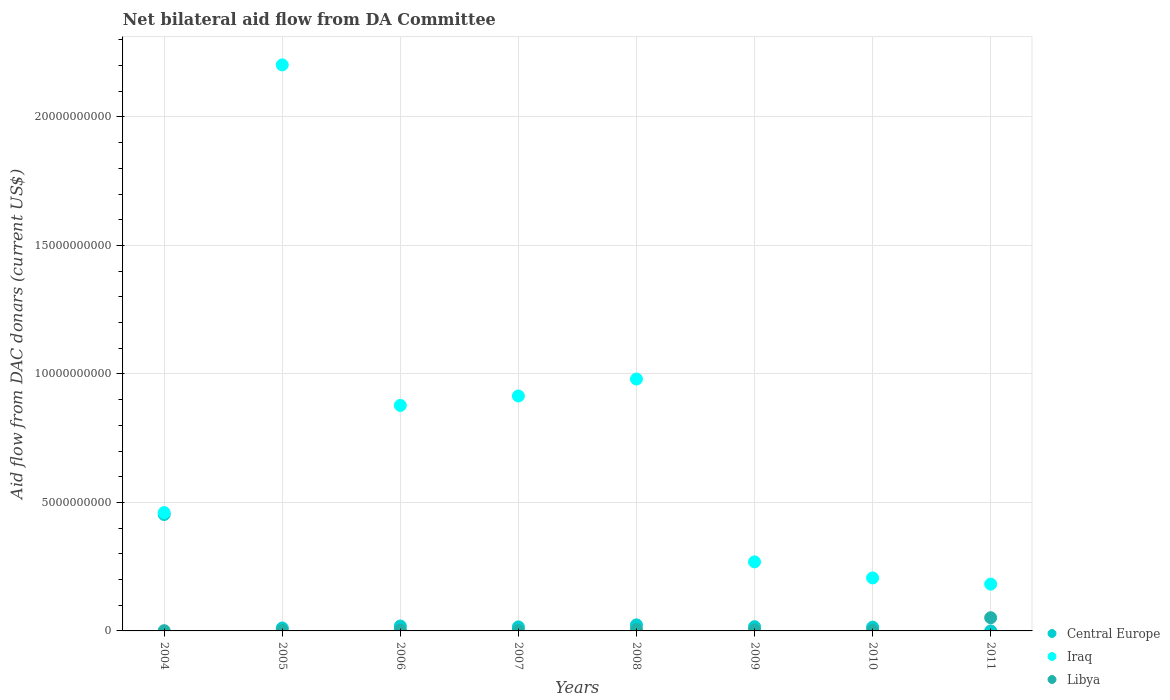How many different coloured dotlines are there?
Your answer should be compact. 3. What is the aid flow in in Libya in 2008?
Provide a succinct answer. 5.66e+07. Across all years, what is the maximum aid flow in in Iraq?
Your answer should be compact. 2.20e+1. Across all years, what is the minimum aid flow in in Iraq?
Your response must be concise. 1.82e+09. In which year was the aid flow in in Iraq minimum?
Ensure brevity in your answer.  2011. What is the total aid flow in in Iraq in the graph?
Your answer should be compact. 6.09e+1. What is the difference between the aid flow in in Central Europe in 2008 and that in 2010?
Provide a short and direct response. 8.90e+07. What is the difference between the aid flow in in Central Europe in 2006 and the aid flow in in Iraq in 2005?
Keep it short and to the point. -2.18e+1. What is the average aid flow in in Iraq per year?
Offer a terse response. 7.62e+09. In the year 2005, what is the difference between the aid flow in in Central Europe and aid flow in in Iraq?
Your answer should be compact. -2.19e+1. In how many years, is the aid flow in in Libya greater than 5000000000 US$?
Ensure brevity in your answer.  0. What is the ratio of the aid flow in in Iraq in 2004 to that in 2011?
Keep it short and to the point. 2.53. Is the aid flow in in Libya in 2004 less than that in 2008?
Make the answer very short. Yes. Is the difference between the aid flow in in Central Europe in 2007 and 2009 greater than the difference between the aid flow in in Iraq in 2007 and 2009?
Give a very brief answer. No. What is the difference between the highest and the second highest aid flow in in Iraq?
Your answer should be compact. 1.22e+1. What is the difference between the highest and the lowest aid flow in in Iraq?
Your answer should be compact. 2.02e+1. Is the aid flow in in Iraq strictly greater than the aid flow in in Libya over the years?
Your answer should be compact. Yes. Is the aid flow in in Libya strictly less than the aid flow in in Central Europe over the years?
Your answer should be compact. No. How many years are there in the graph?
Keep it short and to the point. 8. What is the difference between two consecutive major ticks on the Y-axis?
Offer a terse response. 5.00e+09. Are the values on the major ticks of Y-axis written in scientific E-notation?
Provide a short and direct response. No. Does the graph contain any zero values?
Offer a very short reply. No. Where does the legend appear in the graph?
Make the answer very short. Bottom right. How many legend labels are there?
Your response must be concise. 3. How are the legend labels stacked?
Your response must be concise. Vertical. What is the title of the graph?
Provide a short and direct response. Net bilateral aid flow from DA Committee. What is the label or title of the X-axis?
Make the answer very short. Years. What is the label or title of the Y-axis?
Ensure brevity in your answer.  Aid flow from DAC donars (current US$). What is the Aid flow from DAC donars (current US$) in Central Europe in 2004?
Your answer should be very brief. 4.53e+09. What is the Aid flow from DAC donars (current US$) of Iraq in 2004?
Offer a terse response. 4.61e+09. What is the Aid flow from DAC donars (current US$) in Libya in 2004?
Your response must be concise. 9.70e+06. What is the Aid flow from DAC donars (current US$) of Central Europe in 2005?
Your answer should be very brief. 1.14e+08. What is the Aid flow from DAC donars (current US$) of Iraq in 2005?
Provide a succinct answer. 2.20e+1. What is the Aid flow from DAC donars (current US$) of Libya in 2005?
Your response must be concise. 1.76e+07. What is the Aid flow from DAC donars (current US$) in Central Europe in 2006?
Your answer should be very brief. 1.90e+08. What is the Aid flow from DAC donars (current US$) in Iraq in 2006?
Your answer should be compact. 8.78e+09. What is the Aid flow from DAC donars (current US$) in Libya in 2006?
Ensure brevity in your answer.  3.43e+07. What is the Aid flow from DAC donars (current US$) of Central Europe in 2007?
Offer a very short reply. 1.56e+08. What is the Aid flow from DAC donars (current US$) of Iraq in 2007?
Ensure brevity in your answer.  9.14e+09. What is the Aid flow from DAC donars (current US$) of Libya in 2007?
Give a very brief answer. 1.67e+07. What is the Aid flow from DAC donars (current US$) of Central Europe in 2008?
Offer a very short reply. 2.35e+08. What is the Aid flow from DAC donars (current US$) of Iraq in 2008?
Your response must be concise. 9.80e+09. What is the Aid flow from DAC donars (current US$) in Libya in 2008?
Give a very brief answer. 5.66e+07. What is the Aid flow from DAC donars (current US$) in Central Europe in 2009?
Make the answer very short. 1.65e+08. What is the Aid flow from DAC donars (current US$) of Iraq in 2009?
Your answer should be compact. 2.69e+09. What is the Aid flow from DAC donars (current US$) in Libya in 2009?
Keep it short and to the point. 3.46e+07. What is the Aid flow from DAC donars (current US$) of Central Europe in 2010?
Keep it short and to the point. 1.46e+08. What is the Aid flow from DAC donars (current US$) of Iraq in 2010?
Your response must be concise. 2.06e+09. What is the Aid flow from DAC donars (current US$) of Libya in 2010?
Offer a terse response. 1.84e+07. What is the Aid flow from DAC donars (current US$) of Iraq in 2011?
Make the answer very short. 1.82e+09. What is the Aid flow from DAC donars (current US$) of Libya in 2011?
Your answer should be very brief. 5.14e+08. Across all years, what is the maximum Aid flow from DAC donars (current US$) in Central Europe?
Offer a very short reply. 4.53e+09. Across all years, what is the maximum Aid flow from DAC donars (current US$) of Iraq?
Offer a very short reply. 2.20e+1. Across all years, what is the maximum Aid flow from DAC donars (current US$) of Libya?
Ensure brevity in your answer.  5.14e+08. Across all years, what is the minimum Aid flow from DAC donars (current US$) of Central Europe?
Offer a very short reply. 2.80e+05. Across all years, what is the minimum Aid flow from DAC donars (current US$) of Iraq?
Your response must be concise. 1.82e+09. Across all years, what is the minimum Aid flow from DAC donars (current US$) in Libya?
Give a very brief answer. 9.70e+06. What is the total Aid flow from DAC donars (current US$) in Central Europe in the graph?
Ensure brevity in your answer.  5.54e+09. What is the total Aid flow from DAC donars (current US$) in Iraq in the graph?
Keep it short and to the point. 6.09e+1. What is the total Aid flow from DAC donars (current US$) of Libya in the graph?
Ensure brevity in your answer.  7.02e+08. What is the difference between the Aid flow from DAC donars (current US$) of Central Europe in 2004 and that in 2005?
Provide a succinct answer. 4.42e+09. What is the difference between the Aid flow from DAC donars (current US$) of Iraq in 2004 and that in 2005?
Provide a short and direct response. -1.74e+1. What is the difference between the Aid flow from DAC donars (current US$) in Libya in 2004 and that in 2005?
Your response must be concise. -7.91e+06. What is the difference between the Aid flow from DAC donars (current US$) in Central Europe in 2004 and that in 2006?
Make the answer very short. 4.34e+09. What is the difference between the Aid flow from DAC donars (current US$) in Iraq in 2004 and that in 2006?
Make the answer very short. -4.17e+09. What is the difference between the Aid flow from DAC donars (current US$) in Libya in 2004 and that in 2006?
Offer a very short reply. -2.46e+07. What is the difference between the Aid flow from DAC donars (current US$) in Central Europe in 2004 and that in 2007?
Keep it short and to the point. 4.37e+09. What is the difference between the Aid flow from DAC donars (current US$) of Iraq in 2004 and that in 2007?
Make the answer very short. -4.54e+09. What is the difference between the Aid flow from DAC donars (current US$) of Libya in 2004 and that in 2007?
Your response must be concise. -7.00e+06. What is the difference between the Aid flow from DAC donars (current US$) of Central Europe in 2004 and that in 2008?
Give a very brief answer. 4.30e+09. What is the difference between the Aid flow from DAC donars (current US$) in Iraq in 2004 and that in 2008?
Provide a succinct answer. -5.20e+09. What is the difference between the Aid flow from DAC donars (current US$) in Libya in 2004 and that in 2008?
Your answer should be compact. -4.69e+07. What is the difference between the Aid flow from DAC donars (current US$) of Central Europe in 2004 and that in 2009?
Ensure brevity in your answer.  4.37e+09. What is the difference between the Aid flow from DAC donars (current US$) in Iraq in 2004 and that in 2009?
Provide a short and direct response. 1.92e+09. What is the difference between the Aid flow from DAC donars (current US$) in Libya in 2004 and that in 2009?
Your response must be concise. -2.49e+07. What is the difference between the Aid flow from DAC donars (current US$) in Central Europe in 2004 and that in 2010?
Offer a terse response. 4.38e+09. What is the difference between the Aid flow from DAC donars (current US$) of Iraq in 2004 and that in 2010?
Keep it short and to the point. 2.54e+09. What is the difference between the Aid flow from DAC donars (current US$) in Libya in 2004 and that in 2010?
Your response must be concise. -8.75e+06. What is the difference between the Aid flow from DAC donars (current US$) of Central Europe in 2004 and that in 2011?
Give a very brief answer. 4.53e+09. What is the difference between the Aid flow from DAC donars (current US$) in Iraq in 2004 and that in 2011?
Your response must be concise. 2.78e+09. What is the difference between the Aid flow from DAC donars (current US$) of Libya in 2004 and that in 2011?
Offer a terse response. -5.04e+08. What is the difference between the Aid flow from DAC donars (current US$) of Central Europe in 2005 and that in 2006?
Your answer should be compact. -7.64e+07. What is the difference between the Aid flow from DAC donars (current US$) of Iraq in 2005 and that in 2006?
Ensure brevity in your answer.  1.33e+1. What is the difference between the Aid flow from DAC donars (current US$) of Libya in 2005 and that in 2006?
Keep it short and to the point. -1.67e+07. What is the difference between the Aid flow from DAC donars (current US$) of Central Europe in 2005 and that in 2007?
Give a very brief answer. -4.23e+07. What is the difference between the Aid flow from DAC donars (current US$) of Iraq in 2005 and that in 2007?
Provide a short and direct response. 1.29e+1. What is the difference between the Aid flow from DAC donars (current US$) of Libya in 2005 and that in 2007?
Your response must be concise. 9.10e+05. What is the difference between the Aid flow from DAC donars (current US$) of Central Europe in 2005 and that in 2008?
Offer a terse response. -1.21e+08. What is the difference between the Aid flow from DAC donars (current US$) of Iraq in 2005 and that in 2008?
Ensure brevity in your answer.  1.22e+1. What is the difference between the Aid flow from DAC donars (current US$) in Libya in 2005 and that in 2008?
Provide a short and direct response. -3.90e+07. What is the difference between the Aid flow from DAC donars (current US$) of Central Europe in 2005 and that in 2009?
Your answer should be compact. -5.08e+07. What is the difference between the Aid flow from DAC donars (current US$) of Iraq in 2005 and that in 2009?
Provide a succinct answer. 1.93e+1. What is the difference between the Aid flow from DAC donars (current US$) of Libya in 2005 and that in 2009?
Offer a terse response. -1.70e+07. What is the difference between the Aid flow from DAC donars (current US$) of Central Europe in 2005 and that in 2010?
Your answer should be very brief. -3.20e+07. What is the difference between the Aid flow from DAC donars (current US$) of Iraq in 2005 and that in 2010?
Offer a very short reply. 2.00e+1. What is the difference between the Aid flow from DAC donars (current US$) of Libya in 2005 and that in 2010?
Provide a short and direct response. -8.40e+05. What is the difference between the Aid flow from DAC donars (current US$) in Central Europe in 2005 and that in 2011?
Provide a short and direct response. 1.14e+08. What is the difference between the Aid flow from DAC donars (current US$) of Iraq in 2005 and that in 2011?
Offer a very short reply. 2.02e+1. What is the difference between the Aid flow from DAC donars (current US$) in Libya in 2005 and that in 2011?
Give a very brief answer. -4.96e+08. What is the difference between the Aid flow from DAC donars (current US$) in Central Europe in 2006 and that in 2007?
Your answer should be compact. 3.41e+07. What is the difference between the Aid flow from DAC donars (current US$) in Iraq in 2006 and that in 2007?
Offer a very short reply. -3.67e+08. What is the difference between the Aid flow from DAC donars (current US$) of Libya in 2006 and that in 2007?
Your response must be concise. 1.76e+07. What is the difference between the Aid flow from DAC donars (current US$) of Central Europe in 2006 and that in 2008?
Your response must be concise. -4.46e+07. What is the difference between the Aid flow from DAC donars (current US$) in Iraq in 2006 and that in 2008?
Make the answer very short. -1.03e+09. What is the difference between the Aid flow from DAC donars (current US$) in Libya in 2006 and that in 2008?
Your answer should be compact. -2.23e+07. What is the difference between the Aid flow from DAC donars (current US$) of Central Europe in 2006 and that in 2009?
Your answer should be very brief. 2.56e+07. What is the difference between the Aid flow from DAC donars (current US$) of Iraq in 2006 and that in 2009?
Your answer should be compact. 6.09e+09. What is the difference between the Aid flow from DAC donars (current US$) in Central Europe in 2006 and that in 2010?
Give a very brief answer. 4.43e+07. What is the difference between the Aid flow from DAC donars (current US$) in Iraq in 2006 and that in 2010?
Ensure brevity in your answer.  6.71e+09. What is the difference between the Aid flow from DAC donars (current US$) of Libya in 2006 and that in 2010?
Offer a very short reply. 1.59e+07. What is the difference between the Aid flow from DAC donars (current US$) in Central Europe in 2006 and that in 2011?
Your answer should be compact. 1.90e+08. What is the difference between the Aid flow from DAC donars (current US$) of Iraq in 2006 and that in 2011?
Provide a short and direct response. 6.95e+09. What is the difference between the Aid flow from DAC donars (current US$) of Libya in 2006 and that in 2011?
Offer a terse response. -4.80e+08. What is the difference between the Aid flow from DAC donars (current US$) in Central Europe in 2007 and that in 2008?
Your response must be concise. -7.87e+07. What is the difference between the Aid flow from DAC donars (current US$) in Iraq in 2007 and that in 2008?
Your answer should be compact. -6.60e+08. What is the difference between the Aid flow from DAC donars (current US$) in Libya in 2007 and that in 2008?
Provide a succinct answer. -3.99e+07. What is the difference between the Aid flow from DAC donars (current US$) of Central Europe in 2007 and that in 2009?
Your answer should be compact. -8.51e+06. What is the difference between the Aid flow from DAC donars (current US$) of Iraq in 2007 and that in 2009?
Your response must be concise. 6.46e+09. What is the difference between the Aid flow from DAC donars (current US$) of Libya in 2007 and that in 2009?
Your response must be concise. -1.79e+07. What is the difference between the Aid flow from DAC donars (current US$) in Central Europe in 2007 and that in 2010?
Make the answer very short. 1.03e+07. What is the difference between the Aid flow from DAC donars (current US$) of Iraq in 2007 and that in 2010?
Offer a very short reply. 7.08e+09. What is the difference between the Aid flow from DAC donars (current US$) of Libya in 2007 and that in 2010?
Your answer should be very brief. -1.75e+06. What is the difference between the Aid flow from DAC donars (current US$) of Central Europe in 2007 and that in 2011?
Offer a terse response. 1.56e+08. What is the difference between the Aid flow from DAC donars (current US$) in Iraq in 2007 and that in 2011?
Give a very brief answer. 7.32e+09. What is the difference between the Aid flow from DAC donars (current US$) in Libya in 2007 and that in 2011?
Your response must be concise. -4.97e+08. What is the difference between the Aid flow from DAC donars (current US$) in Central Europe in 2008 and that in 2009?
Give a very brief answer. 7.02e+07. What is the difference between the Aid flow from DAC donars (current US$) of Iraq in 2008 and that in 2009?
Offer a very short reply. 7.12e+09. What is the difference between the Aid flow from DAC donars (current US$) in Libya in 2008 and that in 2009?
Your response must be concise. 2.20e+07. What is the difference between the Aid flow from DAC donars (current US$) of Central Europe in 2008 and that in 2010?
Ensure brevity in your answer.  8.90e+07. What is the difference between the Aid flow from DAC donars (current US$) in Iraq in 2008 and that in 2010?
Provide a short and direct response. 7.74e+09. What is the difference between the Aid flow from DAC donars (current US$) of Libya in 2008 and that in 2010?
Offer a very short reply. 3.81e+07. What is the difference between the Aid flow from DAC donars (current US$) of Central Europe in 2008 and that in 2011?
Your answer should be compact. 2.35e+08. What is the difference between the Aid flow from DAC donars (current US$) of Iraq in 2008 and that in 2011?
Offer a very short reply. 7.98e+09. What is the difference between the Aid flow from DAC donars (current US$) in Libya in 2008 and that in 2011?
Make the answer very short. -4.58e+08. What is the difference between the Aid flow from DAC donars (current US$) in Central Europe in 2009 and that in 2010?
Offer a terse response. 1.88e+07. What is the difference between the Aid flow from DAC donars (current US$) in Iraq in 2009 and that in 2010?
Provide a succinct answer. 6.25e+08. What is the difference between the Aid flow from DAC donars (current US$) of Libya in 2009 and that in 2010?
Keep it short and to the point. 1.61e+07. What is the difference between the Aid flow from DAC donars (current US$) of Central Europe in 2009 and that in 2011?
Your response must be concise. 1.65e+08. What is the difference between the Aid flow from DAC donars (current US$) in Iraq in 2009 and that in 2011?
Give a very brief answer. 8.66e+08. What is the difference between the Aid flow from DAC donars (current US$) in Libya in 2009 and that in 2011?
Your answer should be very brief. -4.80e+08. What is the difference between the Aid flow from DAC donars (current US$) in Central Europe in 2010 and that in 2011?
Make the answer very short. 1.46e+08. What is the difference between the Aid flow from DAC donars (current US$) of Iraq in 2010 and that in 2011?
Keep it short and to the point. 2.41e+08. What is the difference between the Aid flow from DAC donars (current US$) of Libya in 2010 and that in 2011?
Make the answer very short. -4.96e+08. What is the difference between the Aid flow from DAC donars (current US$) in Central Europe in 2004 and the Aid flow from DAC donars (current US$) in Iraq in 2005?
Provide a succinct answer. -1.75e+1. What is the difference between the Aid flow from DAC donars (current US$) of Central Europe in 2004 and the Aid flow from DAC donars (current US$) of Libya in 2005?
Make the answer very short. 4.51e+09. What is the difference between the Aid flow from DAC donars (current US$) of Iraq in 2004 and the Aid flow from DAC donars (current US$) of Libya in 2005?
Give a very brief answer. 4.59e+09. What is the difference between the Aid flow from DAC donars (current US$) of Central Europe in 2004 and the Aid flow from DAC donars (current US$) of Iraq in 2006?
Keep it short and to the point. -4.24e+09. What is the difference between the Aid flow from DAC donars (current US$) in Central Europe in 2004 and the Aid flow from DAC donars (current US$) in Libya in 2006?
Offer a terse response. 4.50e+09. What is the difference between the Aid flow from DAC donars (current US$) of Iraq in 2004 and the Aid flow from DAC donars (current US$) of Libya in 2006?
Ensure brevity in your answer.  4.57e+09. What is the difference between the Aid flow from DAC donars (current US$) of Central Europe in 2004 and the Aid flow from DAC donars (current US$) of Iraq in 2007?
Your answer should be very brief. -4.61e+09. What is the difference between the Aid flow from DAC donars (current US$) in Central Europe in 2004 and the Aid flow from DAC donars (current US$) in Libya in 2007?
Offer a very short reply. 4.51e+09. What is the difference between the Aid flow from DAC donars (current US$) of Iraq in 2004 and the Aid flow from DAC donars (current US$) of Libya in 2007?
Keep it short and to the point. 4.59e+09. What is the difference between the Aid flow from DAC donars (current US$) of Central Europe in 2004 and the Aid flow from DAC donars (current US$) of Iraq in 2008?
Ensure brevity in your answer.  -5.27e+09. What is the difference between the Aid flow from DAC donars (current US$) in Central Europe in 2004 and the Aid flow from DAC donars (current US$) in Libya in 2008?
Provide a succinct answer. 4.47e+09. What is the difference between the Aid flow from DAC donars (current US$) of Iraq in 2004 and the Aid flow from DAC donars (current US$) of Libya in 2008?
Provide a succinct answer. 4.55e+09. What is the difference between the Aid flow from DAC donars (current US$) in Central Europe in 2004 and the Aid flow from DAC donars (current US$) in Iraq in 2009?
Your response must be concise. 1.84e+09. What is the difference between the Aid flow from DAC donars (current US$) in Central Europe in 2004 and the Aid flow from DAC donars (current US$) in Libya in 2009?
Your answer should be compact. 4.50e+09. What is the difference between the Aid flow from DAC donars (current US$) in Iraq in 2004 and the Aid flow from DAC donars (current US$) in Libya in 2009?
Provide a short and direct response. 4.57e+09. What is the difference between the Aid flow from DAC donars (current US$) of Central Europe in 2004 and the Aid flow from DAC donars (current US$) of Iraq in 2010?
Provide a short and direct response. 2.47e+09. What is the difference between the Aid flow from DAC donars (current US$) of Central Europe in 2004 and the Aid flow from DAC donars (current US$) of Libya in 2010?
Give a very brief answer. 4.51e+09. What is the difference between the Aid flow from DAC donars (current US$) of Iraq in 2004 and the Aid flow from DAC donars (current US$) of Libya in 2010?
Make the answer very short. 4.59e+09. What is the difference between the Aid flow from DAC donars (current US$) in Central Europe in 2004 and the Aid flow from DAC donars (current US$) in Iraq in 2011?
Provide a succinct answer. 2.71e+09. What is the difference between the Aid flow from DAC donars (current US$) in Central Europe in 2004 and the Aid flow from DAC donars (current US$) in Libya in 2011?
Your answer should be very brief. 4.02e+09. What is the difference between the Aid flow from DAC donars (current US$) in Iraq in 2004 and the Aid flow from DAC donars (current US$) in Libya in 2011?
Provide a short and direct response. 4.09e+09. What is the difference between the Aid flow from DAC donars (current US$) of Central Europe in 2005 and the Aid flow from DAC donars (current US$) of Iraq in 2006?
Offer a terse response. -8.66e+09. What is the difference between the Aid flow from DAC donars (current US$) in Central Europe in 2005 and the Aid flow from DAC donars (current US$) in Libya in 2006?
Provide a short and direct response. 7.98e+07. What is the difference between the Aid flow from DAC donars (current US$) in Iraq in 2005 and the Aid flow from DAC donars (current US$) in Libya in 2006?
Offer a very short reply. 2.20e+1. What is the difference between the Aid flow from DAC donars (current US$) of Central Europe in 2005 and the Aid flow from DAC donars (current US$) of Iraq in 2007?
Provide a short and direct response. -9.03e+09. What is the difference between the Aid flow from DAC donars (current US$) in Central Europe in 2005 and the Aid flow from DAC donars (current US$) in Libya in 2007?
Make the answer very short. 9.74e+07. What is the difference between the Aid flow from DAC donars (current US$) of Iraq in 2005 and the Aid flow from DAC donars (current US$) of Libya in 2007?
Offer a terse response. 2.20e+1. What is the difference between the Aid flow from DAC donars (current US$) in Central Europe in 2005 and the Aid flow from DAC donars (current US$) in Iraq in 2008?
Provide a short and direct response. -9.69e+09. What is the difference between the Aid flow from DAC donars (current US$) in Central Europe in 2005 and the Aid flow from DAC donars (current US$) in Libya in 2008?
Keep it short and to the point. 5.75e+07. What is the difference between the Aid flow from DAC donars (current US$) in Iraq in 2005 and the Aid flow from DAC donars (current US$) in Libya in 2008?
Your answer should be very brief. 2.20e+1. What is the difference between the Aid flow from DAC donars (current US$) in Central Europe in 2005 and the Aid flow from DAC donars (current US$) in Iraq in 2009?
Make the answer very short. -2.57e+09. What is the difference between the Aid flow from DAC donars (current US$) of Central Europe in 2005 and the Aid flow from DAC donars (current US$) of Libya in 2009?
Make the answer very short. 7.95e+07. What is the difference between the Aid flow from DAC donars (current US$) in Iraq in 2005 and the Aid flow from DAC donars (current US$) in Libya in 2009?
Your answer should be very brief. 2.20e+1. What is the difference between the Aid flow from DAC donars (current US$) of Central Europe in 2005 and the Aid flow from DAC donars (current US$) of Iraq in 2010?
Ensure brevity in your answer.  -1.95e+09. What is the difference between the Aid flow from DAC donars (current US$) in Central Europe in 2005 and the Aid flow from DAC donars (current US$) in Libya in 2010?
Your answer should be very brief. 9.56e+07. What is the difference between the Aid flow from DAC donars (current US$) of Iraq in 2005 and the Aid flow from DAC donars (current US$) of Libya in 2010?
Keep it short and to the point. 2.20e+1. What is the difference between the Aid flow from DAC donars (current US$) of Central Europe in 2005 and the Aid flow from DAC donars (current US$) of Iraq in 2011?
Your answer should be compact. -1.71e+09. What is the difference between the Aid flow from DAC donars (current US$) in Central Europe in 2005 and the Aid flow from DAC donars (current US$) in Libya in 2011?
Your answer should be very brief. -4.00e+08. What is the difference between the Aid flow from DAC donars (current US$) of Iraq in 2005 and the Aid flow from DAC donars (current US$) of Libya in 2011?
Your answer should be compact. 2.15e+1. What is the difference between the Aid flow from DAC donars (current US$) in Central Europe in 2006 and the Aid flow from DAC donars (current US$) in Iraq in 2007?
Offer a very short reply. -8.95e+09. What is the difference between the Aid flow from DAC donars (current US$) of Central Europe in 2006 and the Aid flow from DAC donars (current US$) of Libya in 2007?
Give a very brief answer. 1.74e+08. What is the difference between the Aid flow from DAC donars (current US$) of Iraq in 2006 and the Aid flow from DAC donars (current US$) of Libya in 2007?
Provide a succinct answer. 8.76e+09. What is the difference between the Aid flow from DAC donars (current US$) in Central Europe in 2006 and the Aid flow from DAC donars (current US$) in Iraq in 2008?
Your answer should be very brief. -9.61e+09. What is the difference between the Aid flow from DAC donars (current US$) in Central Europe in 2006 and the Aid flow from DAC donars (current US$) in Libya in 2008?
Provide a short and direct response. 1.34e+08. What is the difference between the Aid flow from DAC donars (current US$) of Iraq in 2006 and the Aid flow from DAC donars (current US$) of Libya in 2008?
Offer a terse response. 8.72e+09. What is the difference between the Aid flow from DAC donars (current US$) in Central Europe in 2006 and the Aid flow from DAC donars (current US$) in Iraq in 2009?
Ensure brevity in your answer.  -2.50e+09. What is the difference between the Aid flow from DAC donars (current US$) of Central Europe in 2006 and the Aid flow from DAC donars (current US$) of Libya in 2009?
Provide a succinct answer. 1.56e+08. What is the difference between the Aid flow from DAC donars (current US$) of Iraq in 2006 and the Aid flow from DAC donars (current US$) of Libya in 2009?
Provide a short and direct response. 8.74e+09. What is the difference between the Aid flow from DAC donars (current US$) of Central Europe in 2006 and the Aid flow from DAC donars (current US$) of Iraq in 2010?
Your answer should be very brief. -1.87e+09. What is the difference between the Aid flow from DAC donars (current US$) in Central Europe in 2006 and the Aid flow from DAC donars (current US$) in Libya in 2010?
Your answer should be compact. 1.72e+08. What is the difference between the Aid flow from DAC donars (current US$) in Iraq in 2006 and the Aid flow from DAC donars (current US$) in Libya in 2010?
Make the answer very short. 8.76e+09. What is the difference between the Aid flow from DAC donars (current US$) of Central Europe in 2006 and the Aid flow from DAC donars (current US$) of Iraq in 2011?
Your response must be concise. -1.63e+09. What is the difference between the Aid flow from DAC donars (current US$) of Central Europe in 2006 and the Aid flow from DAC donars (current US$) of Libya in 2011?
Provide a short and direct response. -3.24e+08. What is the difference between the Aid flow from DAC donars (current US$) of Iraq in 2006 and the Aid flow from DAC donars (current US$) of Libya in 2011?
Provide a short and direct response. 8.26e+09. What is the difference between the Aid flow from DAC donars (current US$) of Central Europe in 2007 and the Aid flow from DAC donars (current US$) of Iraq in 2008?
Ensure brevity in your answer.  -9.65e+09. What is the difference between the Aid flow from DAC donars (current US$) of Central Europe in 2007 and the Aid flow from DAC donars (current US$) of Libya in 2008?
Offer a very short reply. 9.98e+07. What is the difference between the Aid flow from DAC donars (current US$) in Iraq in 2007 and the Aid flow from DAC donars (current US$) in Libya in 2008?
Your answer should be compact. 9.09e+09. What is the difference between the Aid flow from DAC donars (current US$) in Central Europe in 2007 and the Aid flow from DAC donars (current US$) in Iraq in 2009?
Ensure brevity in your answer.  -2.53e+09. What is the difference between the Aid flow from DAC donars (current US$) of Central Europe in 2007 and the Aid flow from DAC donars (current US$) of Libya in 2009?
Ensure brevity in your answer.  1.22e+08. What is the difference between the Aid flow from DAC donars (current US$) of Iraq in 2007 and the Aid flow from DAC donars (current US$) of Libya in 2009?
Provide a succinct answer. 9.11e+09. What is the difference between the Aid flow from DAC donars (current US$) in Central Europe in 2007 and the Aid flow from DAC donars (current US$) in Iraq in 2010?
Make the answer very short. -1.91e+09. What is the difference between the Aid flow from DAC donars (current US$) of Central Europe in 2007 and the Aid flow from DAC donars (current US$) of Libya in 2010?
Offer a terse response. 1.38e+08. What is the difference between the Aid flow from DAC donars (current US$) of Iraq in 2007 and the Aid flow from DAC donars (current US$) of Libya in 2010?
Provide a succinct answer. 9.12e+09. What is the difference between the Aid flow from DAC donars (current US$) in Central Europe in 2007 and the Aid flow from DAC donars (current US$) in Iraq in 2011?
Give a very brief answer. -1.66e+09. What is the difference between the Aid flow from DAC donars (current US$) of Central Europe in 2007 and the Aid flow from DAC donars (current US$) of Libya in 2011?
Your answer should be very brief. -3.58e+08. What is the difference between the Aid flow from DAC donars (current US$) in Iraq in 2007 and the Aid flow from DAC donars (current US$) in Libya in 2011?
Provide a short and direct response. 8.63e+09. What is the difference between the Aid flow from DAC donars (current US$) of Central Europe in 2008 and the Aid flow from DAC donars (current US$) of Iraq in 2009?
Provide a succinct answer. -2.45e+09. What is the difference between the Aid flow from DAC donars (current US$) in Central Europe in 2008 and the Aid flow from DAC donars (current US$) in Libya in 2009?
Give a very brief answer. 2.01e+08. What is the difference between the Aid flow from DAC donars (current US$) of Iraq in 2008 and the Aid flow from DAC donars (current US$) of Libya in 2009?
Your answer should be compact. 9.77e+09. What is the difference between the Aid flow from DAC donars (current US$) of Central Europe in 2008 and the Aid flow from DAC donars (current US$) of Iraq in 2010?
Your answer should be very brief. -1.83e+09. What is the difference between the Aid flow from DAC donars (current US$) in Central Europe in 2008 and the Aid flow from DAC donars (current US$) in Libya in 2010?
Offer a terse response. 2.17e+08. What is the difference between the Aid flow from DAC donars (current US$) in Iraq in 2008 and the Aid flow from DAC donars (current US$) in Libya in 2010?
Give a very brief answer. 9.78e+09. What is the difference between the Aid flow from DAC donars (current US$) in Central Europe in 2008 and the Aid flow from DAC donars (current US$) in Iraq in 2011?
Offer a very short reply. -1.59e+09. What is the difference between the Aid flow from DAC donars (current US$) in Central Europe in 2008 and the Aid flow from DAC donars (current US$) in Libya in 2011?
Keep it short and to the point. -2.79e+08. What is the difference between the Aid flow from DAC donars (current US$) of Iraq in 2008 and the Aid flow from DAC donars (current US$) of Libya in 2011?
Offer a terse response. 9.29e+09. What is the difference between the Aid flow from DAC donars (current US$) of Central Europe in 2009 and the Aid flow from DAC donars (current US$) of Iraq in 2010?
Your answer should be compact. -1.90e+09. What is the difference between the Aid flow from DAC donars (current US$) of Central Europe in 2009 and the Aid flow from DAC donars (current US$) of Libya in 2010?
Keep it short and to the point. 1.46e+08. What is the difference between the Aid flow from DAC donars (current US$) of Iraq in 2009 and the Aid flow from DAC donars (current US$) of Libya in 2010?
Offer a terse response. 2.67e+09. What is the difference between the Aid flow from DAC donars (current US$) in Central Europe in 2009 and the Aid flow from DAC donars (current US$) in Iraq in 2011?
Make the answer very short. -1.66e+09. What is the difference between the Aid flow from DAC donars (current US$) in Central Europe in 2009 and the Aid flow from DAC donars (current US$) in Libya in 2011?
Offer a terse response. -3.49e+08. What is the difference between the Aid flow from DAC donars (current US$) in Iraq in 2009 and the Aid flow from DAC donars (current US$) in Libya in 2011?
Your response must be concise. 2.17e+09. What is the difference between the Aid flow from DAC donars (current US$) of Central Europe in 2010 and the Aid flow from DAC donars (current US$) of Iraq in 2011?
Offer a very short reply. -1.67e+09. What is the difference between the Aid flow from DAC donars (current US$) of Central Europe in 2010 and the Aid flow from DAC donars (current US$) of Libya in 2011?
Make the answer very short. -3.68e+08. What is the difference between the Aid flow from DAC donars (current US$) in Iraq in 2010 and the Aid flow from DAC donars (current US$) in Libya in 2011?
Provide a short and direct response. 1.55e+09. What is the average Aid flow from DAC donars (current US$) of Central Europe per year?
Offer a very short reply. 6.92e+08. What is the average Aid flow from DAC donars (current US$) of Iraq per year?
Keep it short and to the point. 7.62e+09. What is the average Aid flow from DAC donars (current US$) of Libya per year?
Your answer should be very brief. 8.78e+07. In the year 2004, what is the difference between the Aid flow from DAC donars (current US$) in Central Europe and Aid flow from DAC donars (current US$) in Iraq?
Make the answer very short. -7.44e+07. In the year 2004, what is the difference between the Aid flow from DAC donars (current US$) of Central Europe and Aid flow from DAC donars (current US$) of Libya?
Provide a short and direct response. 4.52e+09. In the year 2004, what is the difference between the Aid flow from DAC donars (current US$) of Iraq and Aid flow from DAC donars (current US$) of Libya?
Make the answer very short. 4.60e+09. In the year 2005, what is the difference between the Aid flow from DAC donars (current US$) of Central Europe and Aid flow from DAC donars (current US$) of Iraq?
Make the answer very short. -2.19e+1. In the year 2005, what is the difference between the Aid flow from DAC donars (current US$) in Central Europe and Aid flow from DAC donars (current US$) in Libya?
Provide a succinct answer. 9.65e+07. In the year 2005, what is the difference between the Aid flow from DAC donars (current US$) of Iraq and Aid flow from DAC donars (current US$) of Libya?
Offer a very short reply. 2.20e+1. In the year 2006, what is the difference between the Aid flow from DAC donars (current US$) in Central Europe and Aid flow from DAC donars (current US$) in Iraq?
Ensure brevity in your answer.  -8.59e+09. In the year 2006, what is the difference between the Aid flow from DAC donars (current US$) of Central Europe and Aid flow from DAC donars (current US$) of Libya?
Provide a succinct answer. 1.56e+08. In the year 2006, what is the difference between the Aid flow from DAC donars (current US$) of Iraq and Aid flow from DAC donars (current US$) of Libya?
Give a very brief answer. 8.74e+09. In the year 2007, what is the difference between the Aid flow from DAC donars (current US$) in Central Europe and Aid flow from DAC donars (current US$) in Iraq?
Your answer should be very brief. -8.99e+09. In the year 2007, what is the difference between the Aid flow from DAC donars (current US$) of Central Europe and Aid flow from DAC donars (current US$) of Libya?
Offer a very short reply. 1.40e+08. In the year 2007, what is the difference between the Aid flow from DAC donars (current US$) of Iraq and Aid flow from DAC donars (current US$) of Libya?
Give a very brief answer. 9.13e+09. In the year 2008, what is the difference between the Aid flow from DAC donars (current US$) of Central Europe and Aid flow from DAC donars (current US$) of Iraq?
Keep it short and to the point. -9.57e+09. In the year 2008, what is the difference between the Aid flow from DAC donars (current US$) of Central Europe and Aid flow from DAC donars (current US$) of Libya?
Offer a very short reply. 1.78e+08. In the year 2008, what is the difference between the Aid flow from DAC donars (current US$) of Iraq and Aid flow from DAC donars (current US$) of Libya?
Ensure brevity in your answer.  9.75e+09. In the year 2009, what is the difference between the Aid flow from DAC donars (current US$) in Central Europe and Aid flow from DAC donars (current US$) in Iraq?
Offer a very short reply. -2.52e+09. In the year 2009, what is the difference between the Aid flow from DAC donars (current US$) of Central Europe and Aid flow from DAC donars (current US$) of Libya?
Your response must be concise. 1.30e+08. In the year 2009, what is the difference between the Aid flow from DAC donars (current US$) in Iraq and Aid flow from DAC donars (current US$) in Libya?
Offer a very short reply. 2.65e+09. In the year 2010, what is the difference between the Aid flow from DAC donars (current US$) of Central Europe and Aid flow from DAC donars (current US$) of Iraq?
Provide a short and direct response. -1.92e+09. In the year 2010, what is the difference between the Aid flow from DAC donars (current US$) of Central Europe and Aid flow from DAC donars (current US$) of Libya?
Make the answer very short. 1.28e+08. In the year 2010, what is the difference between the Aid flow from DAC donars (current US$) of Iraq and Aid flow from DAC donars (current US$) of Libya?
Your answer should be very brief. 2.04e+09. In the year 2011, what is the difference between the Aid flow from DAC donars (current US$) in Central Europe and Aid flow from DAC donars (current US$) in Iraq?
Keep it short and to the point. -1.82e+09. In the year 2011, what is the difference between the Aid flow from DAC donars (current US$) of Central Europe and Aid flow from DAC donars (current US$) of Libya?
Ensure brevity in your answer.  -5.14e+08. In the year 2011, what is the difference between the Aid flow from DAC donars (current US$) of Iraq and Aid flow from DAC donars (current US$) of Libya?
Your answer should be very brief. 1.31e+09. What is the ratio of the Aid flow from DAC donars (current US$) in Central Europe in 2004 to that in 2005?
Your answer should be compact. 39.71. What is the ratio of the Aid flow from DAC donars (current US$) in Iraq in 2004 to that in 2005?
Ensure brevity in your answer.  0.21. What is the ratio of the Aid flow from DAC donars (current US$) of Libya in 2004 to that in 2005?
Your response must be concise. 0.55. What is the ratio of the Aid flow from DAC donars (current US$) of Central Europe in 2004 to that in 2006?
Give a very brief answer. 23.79. What is the ratio of the Aid flow from DAC donars (current US$) in Iraq in 2004 to that in 2006?
Provide a short and direct response. 0.52. What is the ratio of the Aid flow from DAC donars (current US$) in Libya in 2004 to that in 2006?
Your answer should be compact. 0.28. What is the ratio of the Aid flow from DAC donars (current US$) in Central Europe in 2004 to that in 2007?
Your answer should be very brief. 28.97. What is the ratio of the Aid flow from DAC donars (current US$) in Iraq in 2004 to that in 2007?
Your answer should be compact. 0.5. What is the ratio of the Aid flow from DAC donars (current US$) in Libya in 2004 to that in 2007?
Make the answer very short. 0.58. What is the ratio of the Aid flow from DAC donars (current US$) of Central Europe in 2004 to that in 2008?
Ensure brevity in your answer.  19.27. What is the ratio of the Aid flow from DAC donars (current US$) in Iraq in 2004 to that in 2008?
Your response must be concise. 0.47. What is the ratio of the Aid flow from DAC donars (current US$) of Libya in 2004 to that in 2008?
Offer a very short reply. 0.17. What is the ratio of the Aid flow from DAC donars (current US$) in Central Europe in 2004 to that in 2009?
Your answer should be very brief. 27.48. What is the ratio of the Aid flow from DAC donars (current US$) of Iraq in 2004 to that in 2009?
Your answer should be compact. 1.71. What is the ratio of the Aid flow from DAC donars (current US$) of Libya in 2004 to that in 2009?
Offer a terse response. 0.28. What is the ratio of the Aid flow from DAC donars (current US$) of Central Europe in 2004 to that in 2010?
Provide a succinct answer. 31.01. What is the ratio of the Aid flow from DAC donars (current US$) of Iraq in 2004 to that in 2010?
Provide a short and direct response. 2.23. What is the ratio of the Aid flow from DAC donars (current US$) in Libya in 2004 to that in 2010?
Your answer should be very brief. 0.53. What is the ratio of the Aid flow from DAC donars (current US$) of Central Europe in 2004 to that in 2011?
Your answer should be compact. 1.62e+04. What is the ratio of the Aid flow from DAC donars (current US$) in Iraq in 2004 to that in 2011?
Offer a terse response. 2.53. What is the ratio of the Aid flow from DAC donars (current US$) of Libya in 2004 to that in 2011?
Ensure brevity in your answer.  0.02. What is the ratio of the Aid flow from DAC donars (current US$) in Central Europe in 2005 to that in 2006?
Offer a terse response. 0.6. What is the ratio of the Aid flow from DAC donars (current US$) in Iraq in 2005 to that in 2006?
Your answer should be compact. 2.51. What is the ratio of the Aid flow from DAC donars (current US$) of Libya in 2005 to that in 2006?
Provide a short and direct response. 0.51. What is the ratio of the Aid flow from DAC donars (current US$) of Central Europe in 2005 to that in 2007?
Ensure brevity in your answer.  0.73. What is the ratio of the Aid flow from DAC donars (current US$) of Iraq in 2005 to that in 2007?
Your answer should be compact. 2.41. What is the ratio of the Aid flow from DAC donars (current US$) of Libya in 2005 to that in 2007?
Give a very brief answer. 1.05. What is the ratio of the Aid flow from DAC donars (current US$) in Central Europe in 2005 to that in 2008?
Offer a terse response. 0.49. What is the ratio of the Aid flow from DAC donars (current US$) of Iraq in 2005 to that in 2008?
Offer a terse response. 2.25. What is the ratio of the Aid flow from DAC donars (current US$) of Libya in 2005 to that in 2008?
Your answer should be compact. 0.31. What is the ratio of the Aid flow from DAC donars (current US$) in Central Europe in 2005 to that in 2009?
Give a very brief answer. 0.69. What is the ratio of the Aid flow from DAC donars (current US$) in Iraq in 2005 to that in 2009?
Your response must be concise. 8.2. What is the ratio of the Aid flow from DAC donars (current US$) of Libya in 2005 to that in 2009?
Give a very brief answer. 0.51. What is the ratio of the Aid flow from DAC donars (current US$) of Central Europe in 2005 to that in 2010?
Your response must be concise. 0.78. What is the ratio of the Aid flow from DAC donars (current US$) in Iraq in 2005 to that in 2010?
Offer a terse response. 10.68. What is the ratio of the Aid flow from DAC donars (current US$) of Libya in 2005 to that in 2010?
Give a very brief answer. 0.95. What is the ratio of the Aid flow from DAC donars (current US$) of Central Europe in 2005 to that in 2011?
Keep it short and to the point. 407.5. What is the ratio of the Aid flow from DAC donars (current US$) in Iraq in 2005 to that in 2011?
Offer a terse response. 12.1. What is the ratio of the Aid flow from DAC donars (current US$) of Libya in 2005 to that in 2011?
Your answer should be very brief. 0.03. What is the ratio of the Aid flow from DAC donars (current US$) of Central Europe in 2006 to that in 2007?
Offer a very short reply. 1.22. What is the ratio of the Aid flow from DAC donars (current US$) in Iraq in 2006 to that in 2007?
Make the answer very short. 0.96. What is the ratio of the Aid flow from DAC donars (current US$) of Libya in 2006 to that in 2007?
Provide a succinct answer. 2.05. What is the ratio of the Aid flow from DAC donars (current US$) in Central Europe in 2006 to that in 2008?
Your answer should be compact. 0.81. What is the ratio of the Aid flow from DAC donars (current US$) in Iraq in 2006 to that in 2008?
Provide a short and direct response. 0.9. What is the ratio of the Aid flow from DAC donars (current US$) in Libya in 2006 to that in 2008?
Offer a very short reply. 0.61. What is the ratio of the Aid flow from DAC donars (current US$) of Central Europe in 2006 to that in 2009?
Offer a very short reply. 1.15. What is the ratio of the Aid flow from DAC donars (current US$) in Iraq in 2006 to that in 2009?
Offer a terse response. 3.27. What is the ratio of the Aid flow from DAC donars (current US$) of Libya in 2006 to that in 2009?
Your answer should be very brief. 0.99. What is the ratio of the Aid flow from DAC donars (current US$) in Central Europe in 2006 to that in 2010?
Your response must be concise. 1.3. What is the ratio of the Aid flow from DAC donars (current US$) in Iraq in 2006 to that in 2010?
Your response must be concise. 4.26. What is the ratio of the Aid flow from DAC donars (current US$) of Libya in 2006 to that in 2010?
Offer a very short reply. 1.86. What is the ratio of the Aid flow from DAC donars (current US$) in Central Europe in 2006 to that in 2011?
Offer a terse response. 680.21. What is the ratio of the Aid flow from DAC donars (current US$) of Iraq in 2006 to that in 2011?
Your answer should be compact. 4.82. What is the ratio of the Aid flow from DAC donars (current US$) in Libya in 2006 to that in 2011?
Keep it short and to the point. 0.07. What is the ratio of the Aid flow from DAC donars (current US$) of Central Europe in 2007 to that in 2008?
Offer a terse response. 0.67. What is the ratio of the Aid flow from DAC donars (current US$) in Iraq in 2007 to that in 2008?
Ensure brevity in your answer.  0.93. What is the ratio of the Aid flow from DAC donars (current US$) of Libya in 2007 to that in 2008?
Provide a short and direct response. 0.3. What is the ratio of the Aid flow from DAC donars (current US$) in Central Europe in 2007 to that in 2009?
Provide a short and direct response. 0.95. What is the ratio of the Aid flow from DAC donars (current US$) of Iraq in 2007 to that in 2009?
Make the answer very short. 3.4. What is the ratio of the Aid flow from DAC donars (current US$) of Libya in 2007 to that in 2009?
Provide a succinct answer. 0.48. What is the ratio of the Aid flow from DAC donars (current US$) in Central Europe in 2007 to that in 2010?
Ensure brevity in your answer.  1.07. What is the ratio of the Aid flow from DAC donars (current US$) in Iraq in 2007 to that in 2010?
Your answer should be compact. 4.43. What is the ratio of the Aid flow from DAC donars (current US$) of Libya in 2007 to that in 2010?
Provide a succinct answer. 0.91. What is the ratio of the Aid flow from DAC donars (current US$) of Central Europe in 2007 to that in 2011?
Make the answer very short. 558.57. What is the ratio of the Aid flow from DAC donars (current US$) in Iraq in 2007 to that in 2011?
Your answer should be very brief. 5.02. What is the ratio of the Aid flow from DAC donars (current US$) in Libya in 2007 to that in 2011?
Offer a terse response. 0.03. What is the ratio of the Aid flow from DAC donars (current US$) of Central Europe in 2008 to that in 2009?
Your response must be concise. 1.43. What is the ratio of the Aid flow from DAC donars (current US$) in Iraq in 2008 to that in 2009?
Make the answer very short. 3.65. What is the ratio of the Aid flow from DAC donars (current US$) of Libya in 2008 to that in 2009?
Give a very brief answer. 1.64. What is the ratio of the Aid flow from DAC donars (current US$) of Central Europe in 2008 to that in 2010?
Make the answer very short. 1.61. What is the ratio of the Aid flow from DAC donars (current US$) in Iraq in 2008 to that in 2010?
Give a very brief answer. 4.75. What is the ratio of the Aid flow from DAC donars (current US$) of Libya in 2008 to that in 2010?
Your response must be concise. 3.07. What is the ratio of the Aid flow from DAC donars (current US$) of Central Europe in 2008 to that in 2011?
Give a very brief answer. 839.57. What is the ratio of the Aid flow from DAC donars (current US$) of Iraq in 2008 to that in 2011?
Offer a terse response. 5.38. What is the ratio of the Aid flow from DAC donars (current US$) of Libya in 2008 to that in 2011?
Provide a succinct answer. 0.11. What is the ratio of the Aid flow from DAC donars (current US$) of Central Europe in 2009 to that in 2010?
Your answer should be compact. 1.13. What is the ratio of the Aid flow from DAC donars (current US$) in Iraq in 2009 to that in 2010?
Provide a short and direct response. 1.3. What is the ratio of the Aid flow from DAC donars (current US$) in Libya in 2009 to that in 2010?
Provide a succinct answer. 1.87. What is the ratio of the Aid flow from DAC donars (current US$) in Central Europe in 2009 to that in 2011?
Make the answer very short. 588.96. What is the ratio of the Aid flow from DAC donars (current US$) of Iraq in 2009 to that in 2011?
Ensure brevity in your answer.  1.48. What is the ratio of the Aid flow from DAC donars (current US$) of Libya in 2009 to that in 2011?
Provide a short and direct response. 0.07. What is the ratio of the Aid flow from DAC donars (current US$) in Central Europe in 2010 to that in 2011?
Your answer should be very brief. 521.86. What is the ratio of the Aid flow from DAC donars (current US$) of Iraq in 2010 to that in 2011?
Keep it short and to the point. 1.13. What is the ratio of the Aid flow from DAC donars (current US$) in Libya in 2010 to that in 2011?
Your answer should be compact. 0.04. What is the difference between the highest and the second highest Aid flow from DAC donars (current US$) in Central Europe?
Your answer should be compact. 4.30e+09. What is the difference between the highest and the second highest Aid flow from DAC donars (current US$) in Iraq?
Offer a terse response. 1.22e+1. What is the difference between the highest and the second highest Aid flow from DAC donars (current US$) in Libya?
Ensure brevity in your answer.  4.58e+08. What is the difference between the highest and the lowest Aid flow from DAC donars (current US$) in Central Europe?
Ensure brevity in your answer.  4.53e+09. What is the difference between the highest and the lowest Aid flow from DAC donars (current US$) in Iraq?
Make the answer very short. 2.02e+1. What is the difference between the highest and the lowest Aid flow from DAC donars (current US$) in Libya?
Provide a short and direct response. 5.04e+08. 